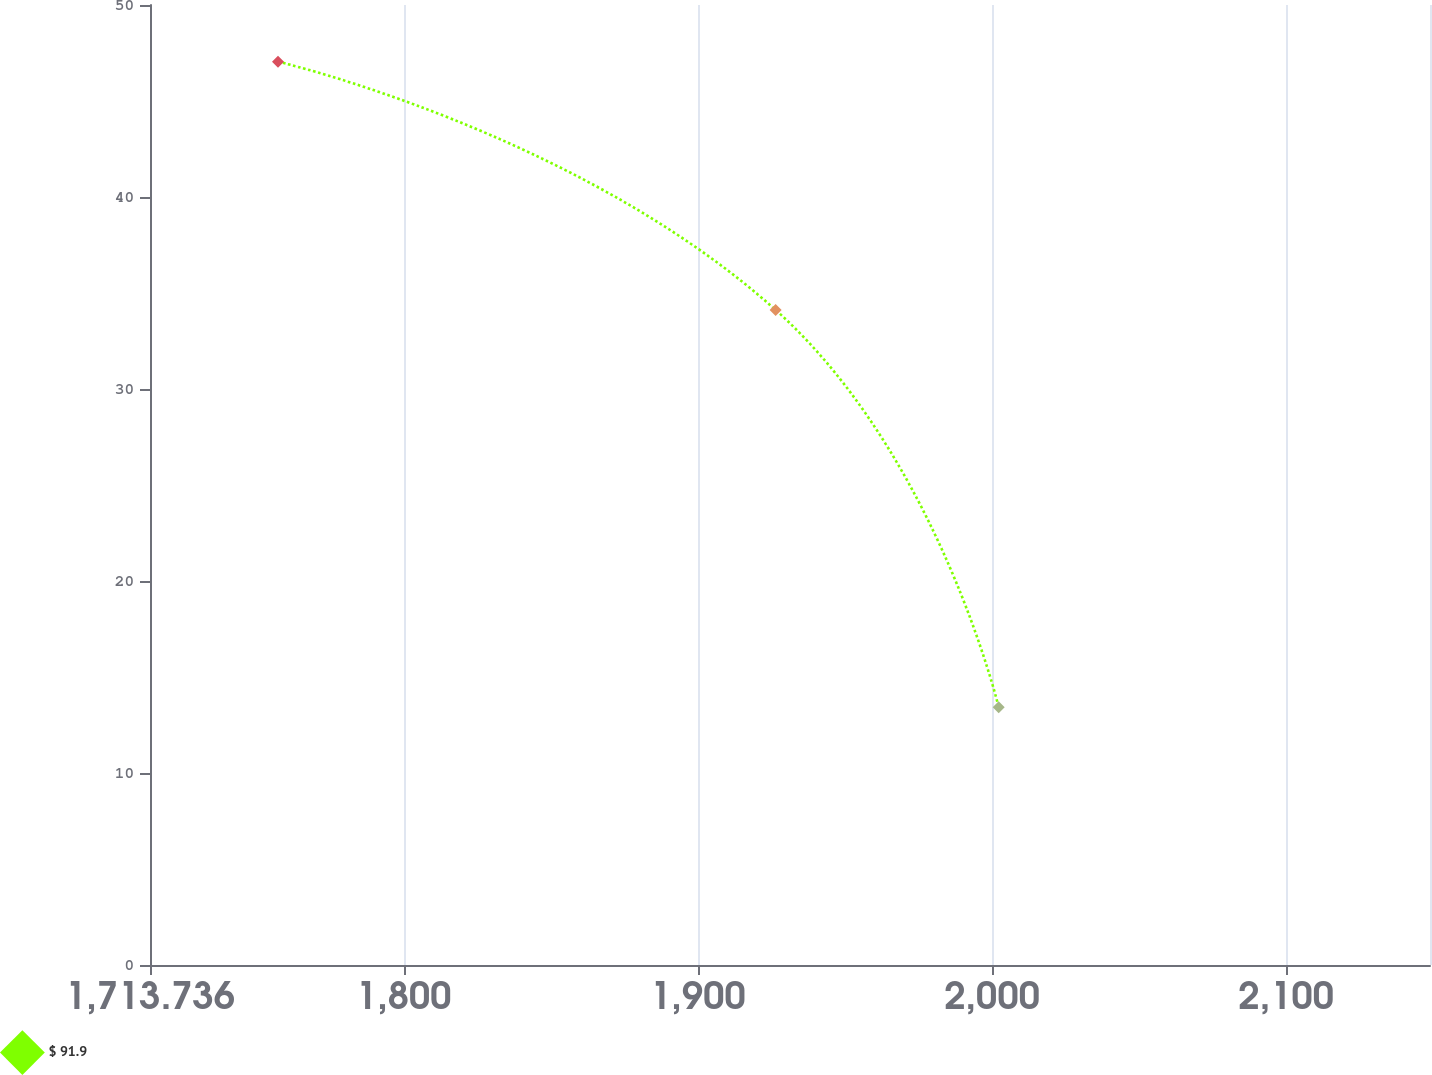<chart> <loc_0><loc_0><loc_500><loc_500><line_chart><ecel><fcel>$ 91.9<nl><fcel>1757.25<fcel>47.05<nl><fcel>1926.41<fcel>34.12<nl><fcel>2002.26<fcel>13.42<nl><fcel>2192.39<fcel>0.37<nl></chart> 